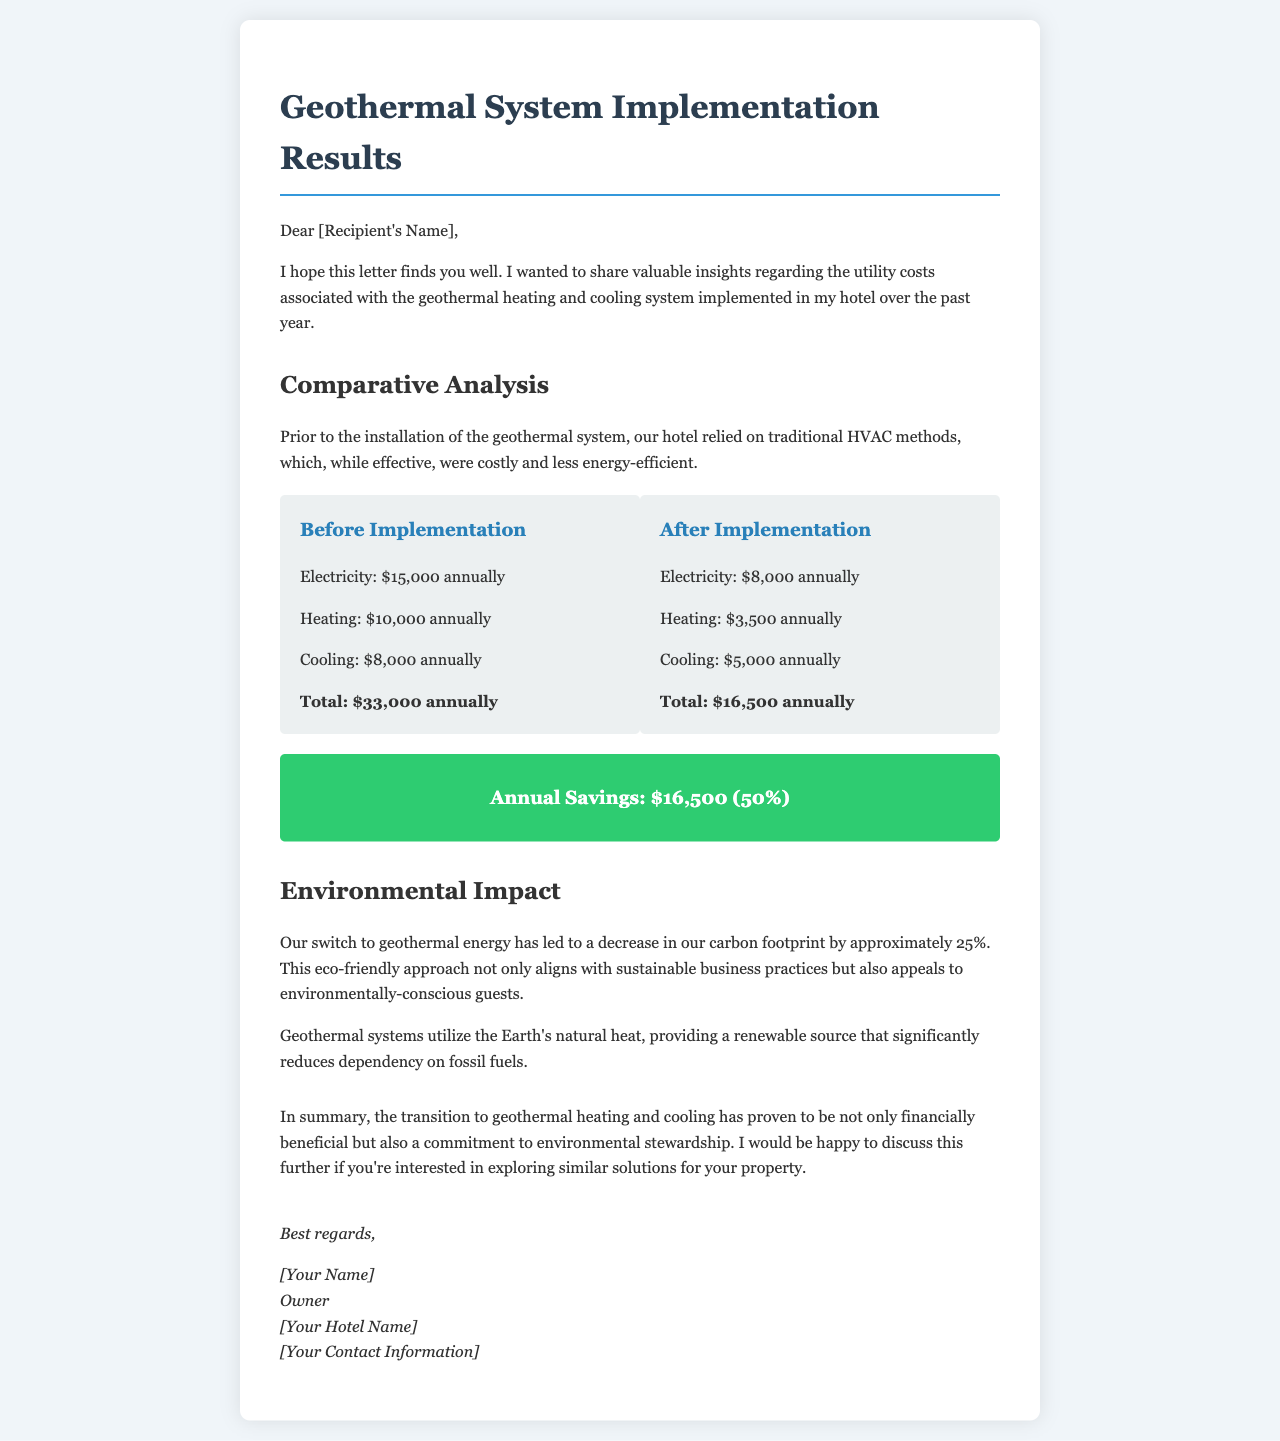What were the utility costs before implementation? The document lists the total utility costs before implementing the geothermal system as $33,000 annually.
Answer: $33,000 annually What is the annual savings after implementation? The savings are calculated as the difference between total costs before and after implementation, which is stated as $16,500 (50%).
Answer: $16,500 (50%) How much did electricity cost annually after implementation? The document specifies that electricity costs were $8,000 annually after the geothermal system was installed.
Answer: $8,000 annually What was the reduction in carbon footprint approximately? The letter mentions that the switch to geothermal energy led to a decrease in the carbon footprint by approximately 25%.
Answer: 25% What is the total cost of heating before implementation? According to the cost breakdown, heating costs prior to implementation were $10,000 annually.
Answer: $10,000 annually What other benefits does geothermal energy provide according to the document? The document states that it reduces dependency on fossil fuels, which is an environmental benefit of geothermal energy.
Answer: Reduces dependency on fossil fuels Who is the author of the letter? The letter is signed by the hotel owner, referred to as [Your Name].
Answer: [Your Name] 